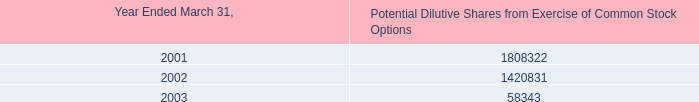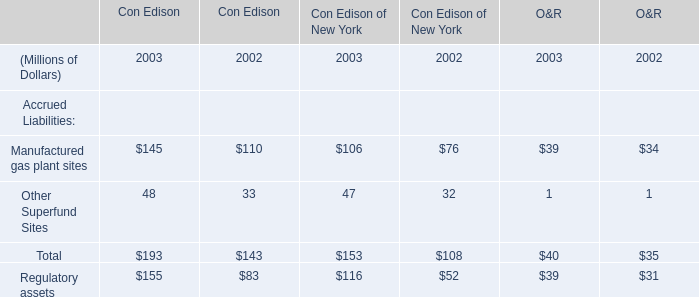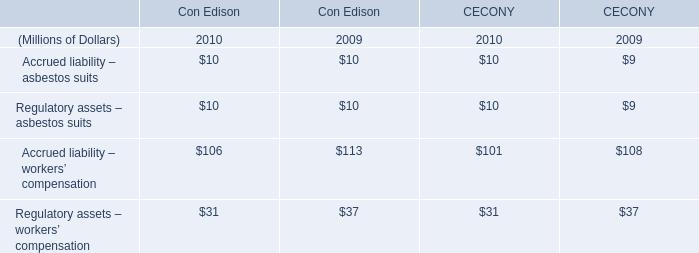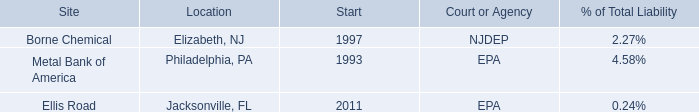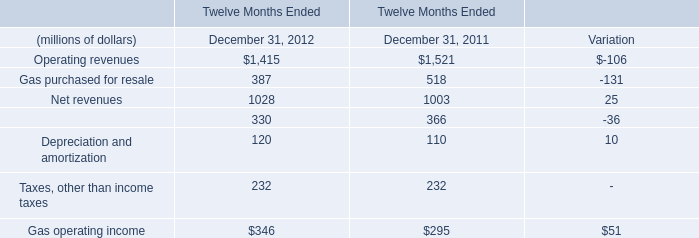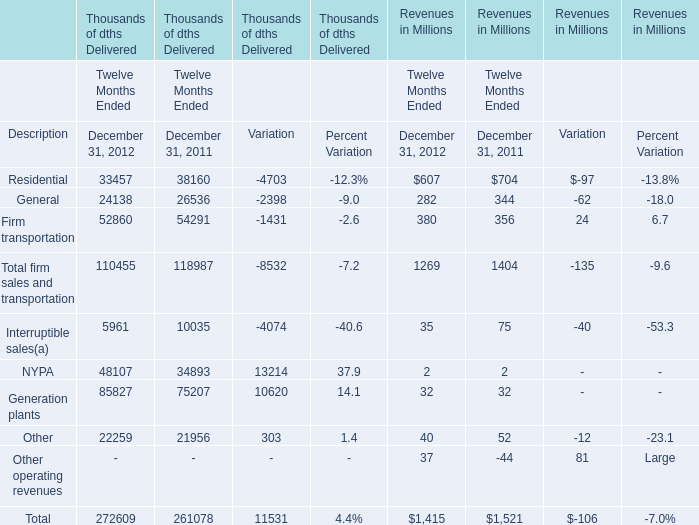What is the growing rate of Net revenues in the years with the least Operating revenues? 
Computations: (25 / 1028)
Answer: 0.02432. 